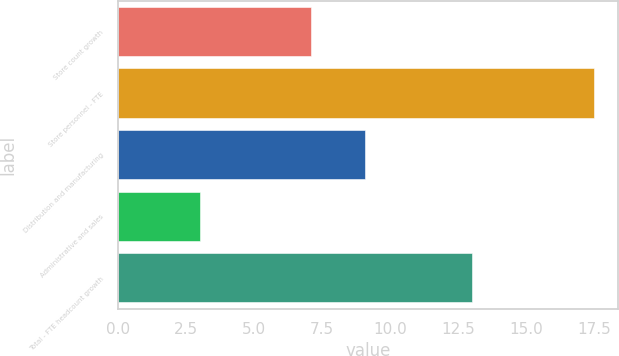<chart> <loc_0><loc_0><loc_500><loc_500><bar_chart><fcel>Store count growth<fcel>Store personnel - FTE<fcel>Distribution and manufacturing<fcel>Administrative and sales<fcel>Total - FTE headcount growth<nl><fcel>7.1<fcel>17.5<fcel>9.1<fcel>3<fcel>13<nl></chart> 